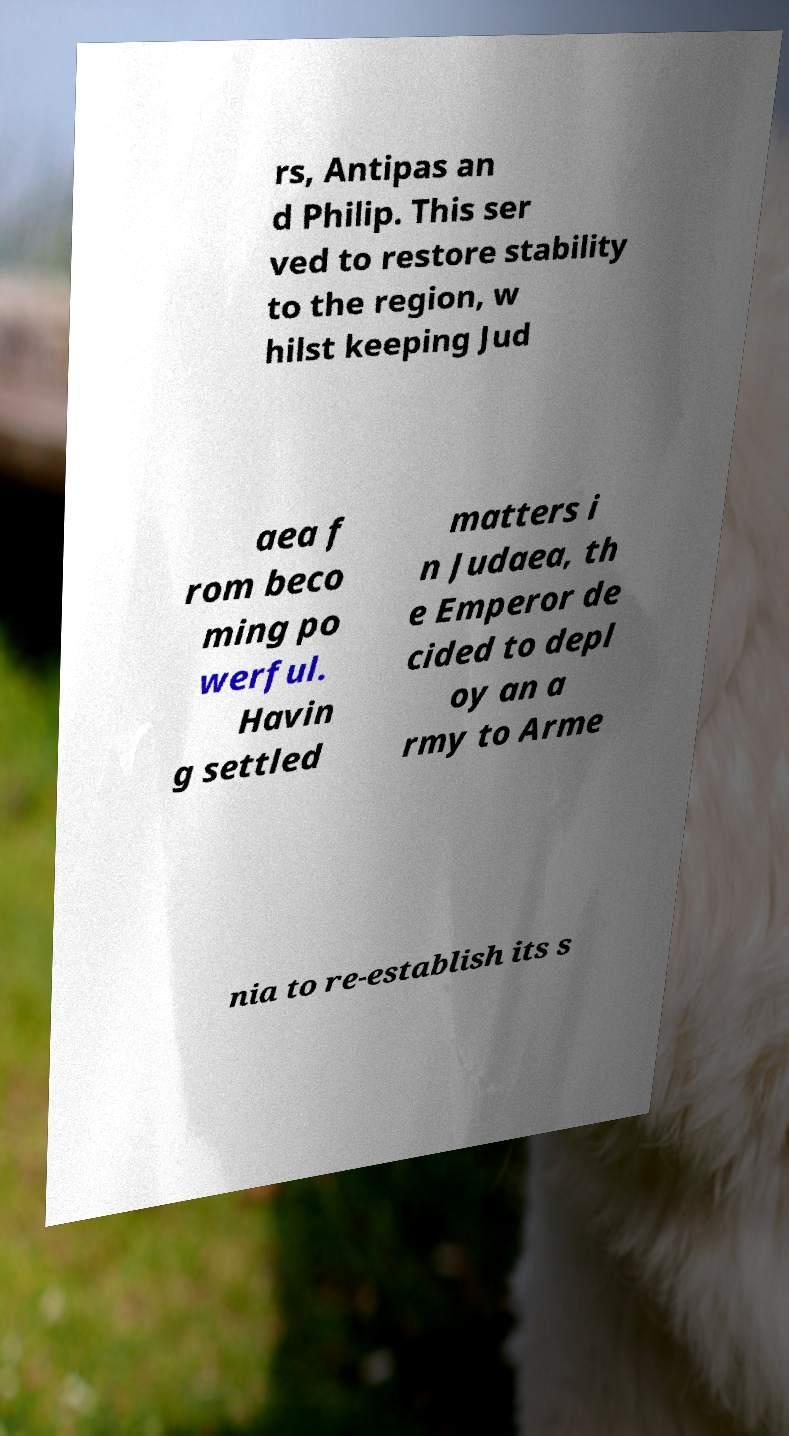Please identify and transcribe the text found in this image. rs, Antipas an d Philip. This ser ved to restore stability to the region, w hilst keeping Jud aea f rom beco ming po werful. Havin g settled matters i n Judaea, th e Emperor de cided to depl oy an a rmy to Arme nia to re-establish its s 